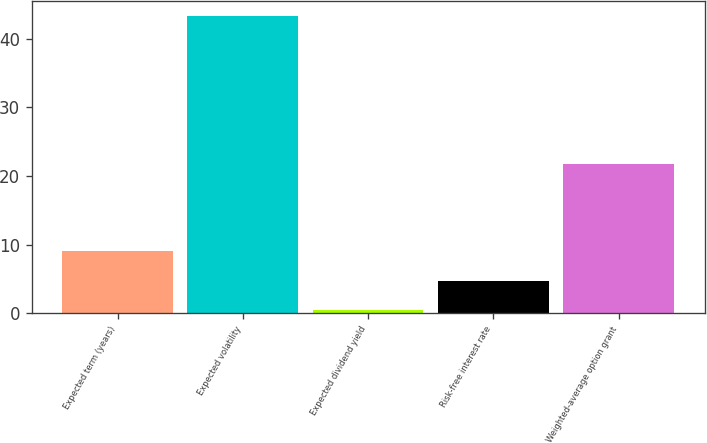<chart> <loc_0><loc_0><loc_500><loc_500><bar_chart><fcel>Expected term (years)<fcel>Expected volatility<fcel>Expected dividend yield<fcel>Risk-free interest rate<fcel>Weighted-average option grant<nl><fcel>9.02<fcel>43.3<fcel>0.46<fcel>4.74<fcel>21.77<nl></chart> 